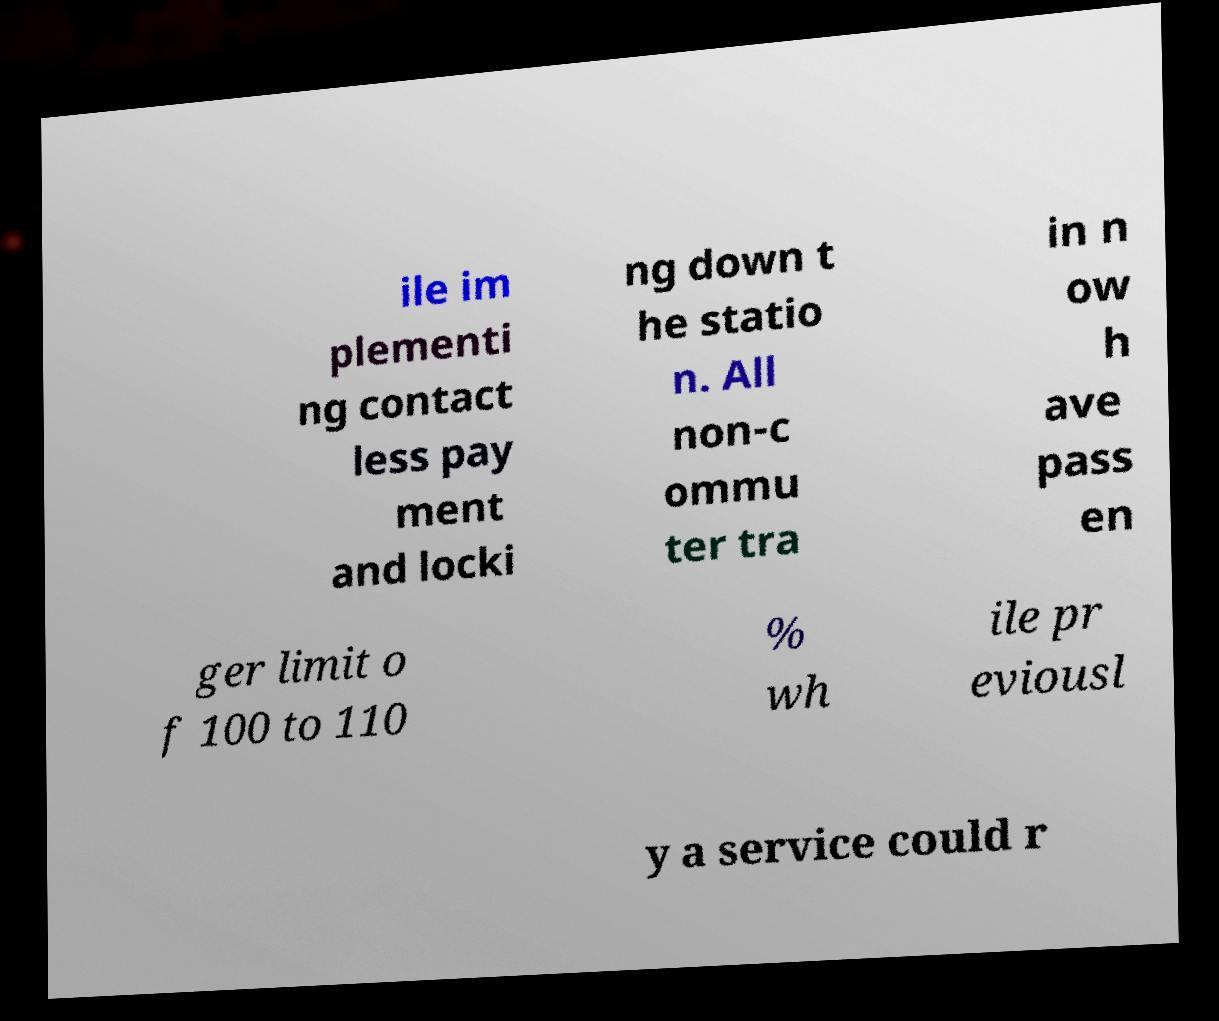Please read and relay the text visible in this image. What does it say? ile im plementi ng contact less pay ment and locki ng down t he statio n. All non-c ommu ter tra in n ow h ave pass en ger limit o f 100 to 110 % wh ile pr eviousl y a service could r 